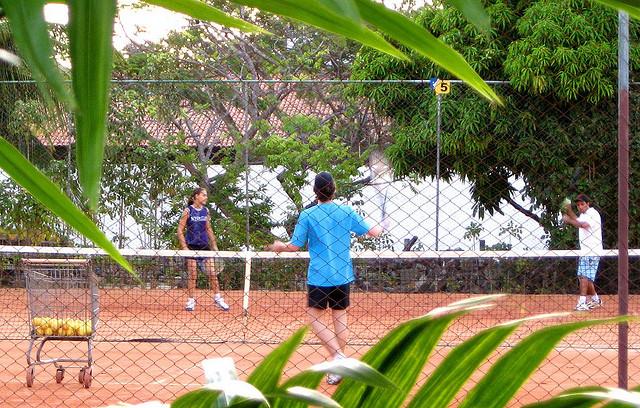What are they playing on the playing field?
Quick response, please. Tennis. What surrounds the playing field?
Give a very brief answer. Fence. What is in the shopping cart?
Write a very short answer. Tennis balls. 